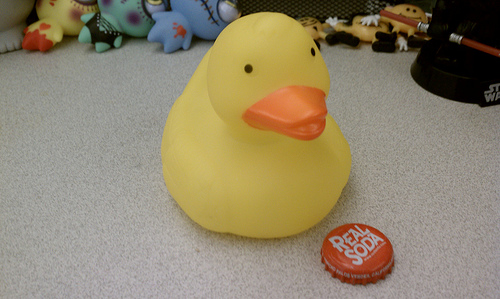<image>
Can you confirm if the doll is behind the cap? Yes. From this viewpoint, the doll is positioned behind the cap, with the cap partially or fully occluding the doll. 